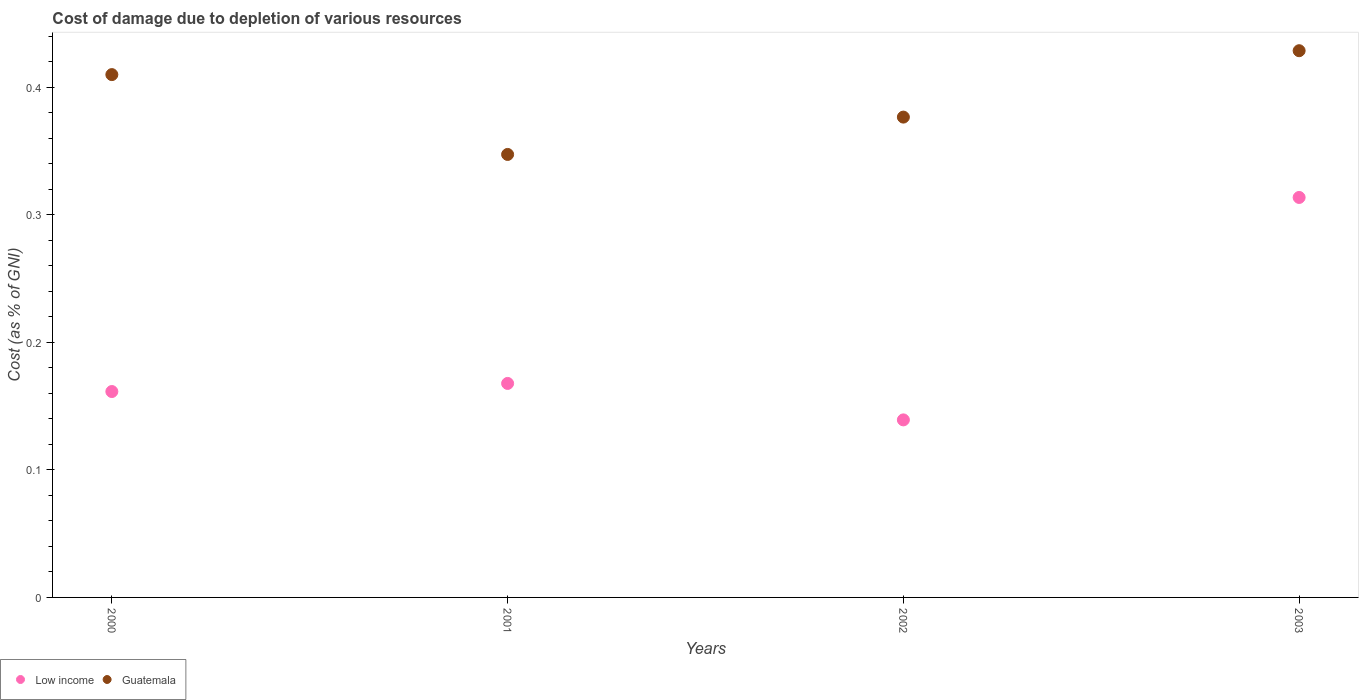How many different coloured dotlines are there?
Ensure brevity in your answer.  2. Is the number of dotlines equal to the number of legend labels?
Ensure brevity in your answer.  Yes. What is the cost of damage caused due to the depletion of various resources in Guatemala in 2002?
Make the answer very short. 0.38. Across all years, what is the maximum cost of damage caused due to the depletion of various resources in Low income?
Your response must be concise. 0.31. Across all years, what is the minimum cost of damage caused due to the depletion of various resources in Guatemala?
Your answer should be very brief. 0.35. In which year was the cost of damage caused due to the depletion of various resources in Low income minimum?
Your response must be concise. 2002. What is the total cost of damage caused due to the depletion of various resources in Low income in the graph?
Make the answer very short. 0.78. What is the difference between the cost of damage caused due to the depletion of various resources in Guatemala in 2000 and that in 2001?
Provide a succinct answer. 0.06. What is the difference between the cost of damage caused due to the depletion of various resources in Low income in 2002 and the cost of damage caused due to the depletion of various resources in Guatemala in 2001?
Offer a terse response. -0.21. What is the average cost of damage caused due to the depletion of various resources in Low income per year?
Your answer should be very brief. 0.2. In the year 2000, what is the difference between the cost of damage caused due to the depletion of various resources in Low income and cost of damage caused due to the depletion of various resources in Guatemala?
Give a very brief answer. -0.25. In how many years, is the cost of damage caused due to the depletion of various resources in Low income greater than 0.26 %?
Your response must be concise. 1. What is the ratio of the cost of damage caused due to the depletion of various resources in Guatemala in 2001 to that in 2003?
Your response must be concise. 0.81. What is the difference between the highest and the second highest cost of damage caused due to the depletion of various resources in Guatemala?
Ensure brevity in your answer.  0.02. What is the difference between the highest and the lowest cost of damage caused due to the depletion of various resources in Low income?
Keep it short and to the point. 0.17. Is the sum of the cost of damage caused due to the depletion of various resources in Guatemala in 2001 and 2002 greater than the maximum cost of damage caused due to the depletion of various resources in Low income across all years?
Offer a terse response. Yes. Does the cost of damage caused due to the depletion of various resources in Guatemala monotonically increase over the years?
Offer a very short reply. No. Is the cost of damage caused due to the depletion of various resources in Guatemala strictly less than the cost of damage caused due to the depletion of various resources in Low income over the years?
Make the answer very short. No. How many dotlines are there?
Keep it short and to the point. 2. How many years are there in the graph?
Make the answer very short. 4. What is the difference between two consecutive major ticks on the Y-axis?
Offer a very short reply. 0.1. Are the values on the major ticks of Y-axis written in scientific E-notation?
Offer a very short reply. No. Does the graph contain any zero values?
Ensure brevity in your answer.  No. Where does the legend appear in the graph?
Provide a short and direct response. Bottom left. How many legend labels are there?
Ensure brevity in your answer.  2. What is the title of the graph?
Keep it short and to the point. Cost of damage due to depletion of various resources. What is the label or title of the Y-axis?
Keep it short and to the point. Cost (as % of GNI). What is the Cost (as % of GNI) in Low income in 2000?
Give a very brief answer. 0.16. What is the Cost (as % of GNI) in Guatemala in 2000?
Make the answer very short. 0.41. What is the Cost (as % of GNI) of Low income in 2001?
Keep it short and to the point. 0.17. What is the Cost (as % of GNI) in Guatemala in 2001?
Ensure brevity in your answer.  0.35. What is the Cost (as % of GNI) of Low income in 2002?
Provide a short and direct response. 0.14. What is the Cost (as % of GNI) of Guatemala in 2002?
Your answer should be very brief. 0.38. What is the Cost (as % of GNI) of Low income in 2003?
Offer a very short reply. 0.31. What is the Cost (as % of GNI) in Guatemala in 2003?
Offer a very short reply. 0.43. Across all years, what is the maximum Cost (as % of GNI) in Low income?
Keep it short and to the point. 0.31. Across all years, what is the maximum Cost (as % of GNI) in Guatemala?
Make the answer very short. 0.43. Across all years, what is the minimum Cost (as % of GNI) in Low income?
Your answer should be compact. 0.14. Across all years, what is the minimum Cost (as % of GNI) in Guatemala?
Provide a short and direct response. 0.35. What is the total Cost (as % of GNI) in Low income in the graph?
Give a very brief answer. 0.78. What is the total Cost (as % of GNI) of Guatemala in the graph?
Your answer should be very brief. 1.56. What is the difference between the Cost (as % of GNI) of Low income in 2000 and that in 2001?
Your response must be concise. -0.01. What is the difference between the Cost (as % of GNI) of Guatemala in 2000 and that in 2001?
Your answer should be very brief. 0.06. What is the difference between the Cost (as % of GNI) of Low income in 2000 and that in 2002?
Provide a short and direct response. 0.02. What is the difference between the Cost (as % of GNI) of Low income in 2000 and that in 2003?
Your response must be concise. -0.15. What is the difference between the Cost (as % of GNI) of Guatemala in 2000 and that in 2003?
Make the answer very short. -0.02. What is the difference between the Cost (as % of GNI) in Low income in 2001 and that in 2002?
Your response must be concise. 0.03. What is the difference between the Cost (as % of GNI) in Guatemala in 2001 and that in 2002?
Keep it short and to the point. -0.03. What is the difference between the Cost (as % of GNI) in Low income in 2001 and that in 2003?
Make the answer very short. -0.15. What is the difference between the Cost (as % of GNI) in Guatemala in 2001 and that in 2003?
Your response must be concise. -0.08. What is the difference between the Cost (as % of GNI) in Low income in 2002 and that in 2003?
Your answer should be compact. -0.17. What is the difference between the Cost (as % of GNI) of Guatemala in 2002 and that in 2003?
Provide a succinct answer. -0.05. What is the difference between the Cost (as % of GNI) in Low income in 2000 and the Cost (as % of GNI) in Guatemala in 2001?
Provide a short and direct response. -0.19. What is the difference between the Cost (as % of GNI) of Low income in 2000 and the Cost (as % of GNI) of Guatemala in 2002?
Make the answer very short. -0.22. What is the difference between the Cost (as % of GNI) of Low income in 2000 and the Cost (as % of GNI) of Guatemala in 2003?
Keep it short and to the point. -0.27. What is the difference between the Cost (as % of GNI) of Low income in 2001 and the Cost (as % of GNI) of Guatemala in 2002?
Offer a terse response. -0.21. What is the difference between the Cost (as % of GNI) of Low income in 2001 and the Cost (as % of GNI) of Guatemala in 2003?
Make the answer very short. -0.26. What is the difference between the Cost (as % of GNI) of Low income in 2002 and the Cost (as % of GNI) of Guatemala in 2003?
Keep it short and to the point. -0.29. What is the average Cost (as % of GNI) in Low income per year?
Offer a very short reply. 0.2. What is the average Cost (as % of GNI) in Guatemala per year?
Offer a very short reply. 0.39. In the year 2000, what is the difference between the Cost (as % of GNI) in Low income and Cost (as % of GNI) in Guatemala?
Offer a very short reply. -0.25. In the year 2001, what is the difference between the Cost (as % of GNI) of Low income and Cost (as % of GNI) of Guatemala?
Your response must be concise. -0.18. In the year 2002, what is the difference between the Cost (as % of GNI) in Low income and Cost (as % of GNI) in Guatemala?
Your response must be concise. -0.24. In the year 2003, what is the difference between the Cost (as % of GNI) of Low income and Cost (as % of GNI) of Guatemala?
Your answer should be very brief. -0.12. What is the ratio of the Cost (as % of GNI) in Low income in 2000 to that in 2001?
Keep it short and to the point. 0.96. What is the ratio of the Cost (as % of GNI) of Guatemala in 2000 to that in 2001?
Provide a short and direct response. 1.18. What is the ratio of the Cost (as % of GNI) of Low income in 2000 to that in 2002?
Give a very brief answer. 1.16. What is the ratio of the Cost (as % of GNI) of Guatemala in 2000 to that in 2002?
Ensure brevity in your answer.  1.09. What is the ratio of the Cost (as % of GNI) in Low income in 2000 to that in 2003?
Provide a short and direct response. 0.51. What is the ratio of the Cost (as % of GNI) in Guatemala in 2000 to that in 2003?
Make the answer very short. 0.96. What is the ratio of the Cost (as % of GNI) of Low income in 2001 to that in 2002?
Give a very brief answer. 1.21. What is the ratio of the Cost (as % of GNI) in Guatemala in 2001 to that in 2002?
Your answer should be very brief. 0.92. What is the ratio of the Cost (as % of GNI) of Low income in 2001 to that in 2003?
Provide a short and direct response. 0.54. What is the ratio of the Cost (as % of GNI) in Guatemala in 2001 to that in 2003?
Give a very brief answer. 0.81. What is the ratio of the Cost (as % of GNI) of Low income in 2002 to that in 2003?
Ensure brevity in your answer.  0.44. What is the ratio of the Cost (as % of GNI) of Guatemala in 2002 to that in 2003?
Your answer should be compact. 0.88. What is the difference between the highest and the second highest Cost (as % of GNI) in Low income?
Keep it short and to the point. 0.15. What is the difference between the highest and the second highest Cost (as % of GNI) of Guatemala?
Your answer should be very brief. 0.02. What is the difference between the highest and the lowest Cost (as % of GNI) in Low income?
Give a very brief answer. 0.17. What is the difference between the highest and the lowest Cost (as % of GNI) in Guatemala?
Your answer should be compact. 0.08. 